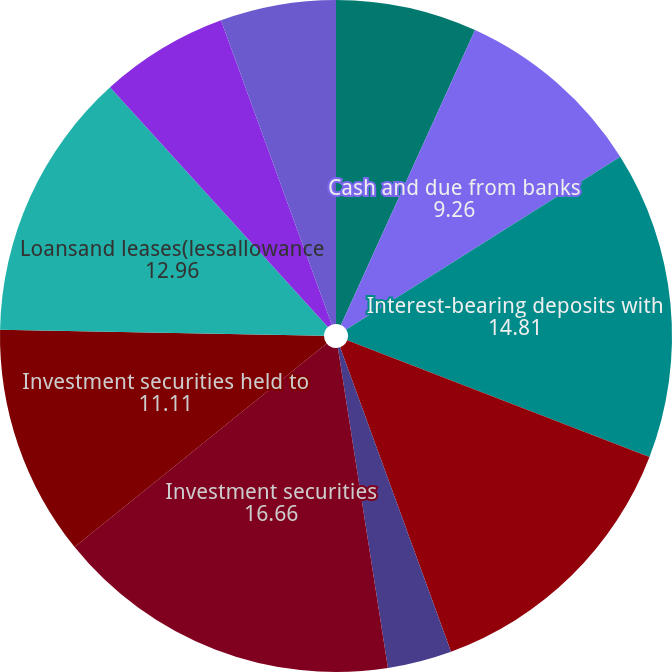Convert chart. <chart><loc_0><loc_0><loc_500><loc_500><pie_chart><fcel>As of December 31<fcel>Cash and due from banks<fcel>Interest-bearing deposits with<fcel>Securities purchased under<fcel>Trading account assets<fcel>Investment securities<fcel>Investment securities held to<fcel>Loansand leases(lessallowance<fcel>Premises and equipment (net of<fcel>Accrued income receivable<nl><fcel>6.79%<fcel>9.26%<fcel>14.81%<fcel>13.58%<fcel>3.09%<fcel>16.66%<fcel>11.11%<fcel>12.96%<fcel>6.18%<fcel>5.56%<nl></chart> 